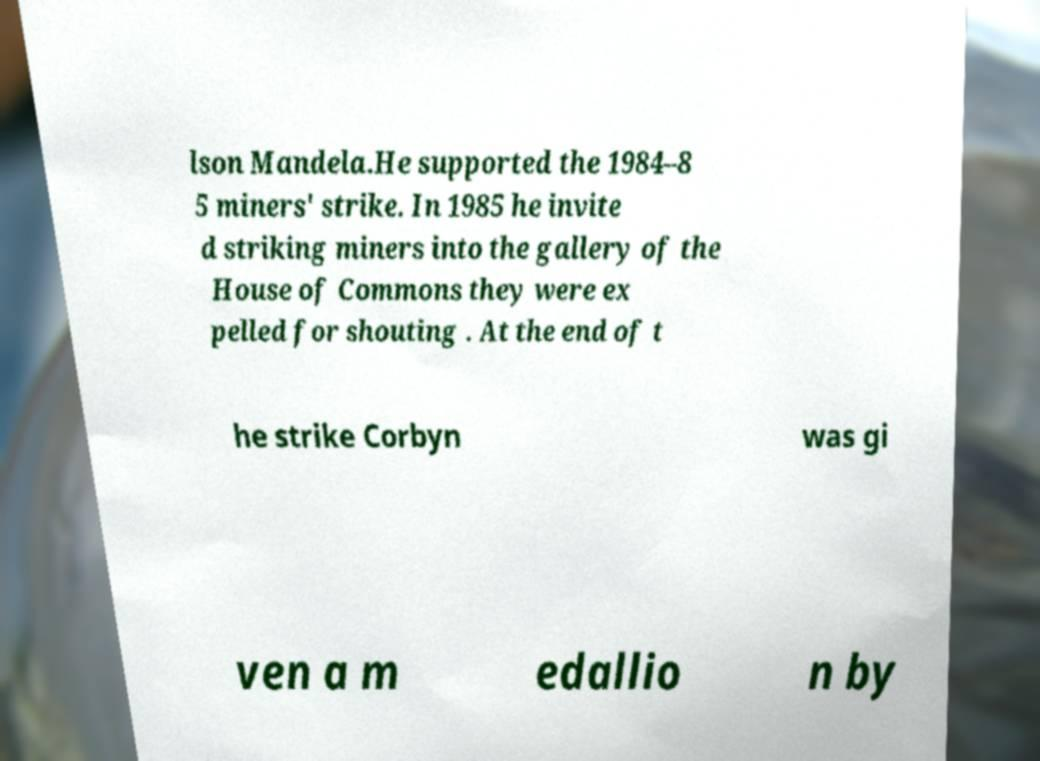Can you read and provide the text displayed in the image?This photo seems to have some interesting text. Can you extract and type it out for me? lson Mandela.He supported the 1984–8 5 miners' strike. In 1985 he invite d striking miners into the gallery of the House of Commons they were ex pelled for shouting . At the end of t he strike Corbyn was gi ven a m edallio n by 